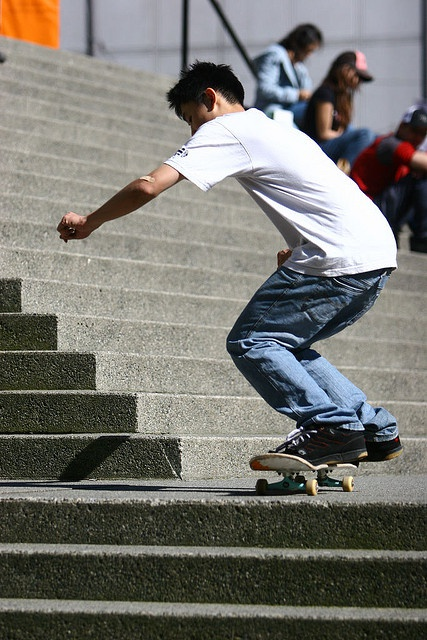Describe the objects in this image and their specific colors. I can see people in salmon, white, black, gray, and darkgray tones, people in salmon, black, maroon, brown, and gray tones, people in salmon, black, maroon, navy, and gray tones, people in salmon, black, darkgray, and lightblue tones, and skateboard in salmon, black, gray, and darkgray tones in this image. 